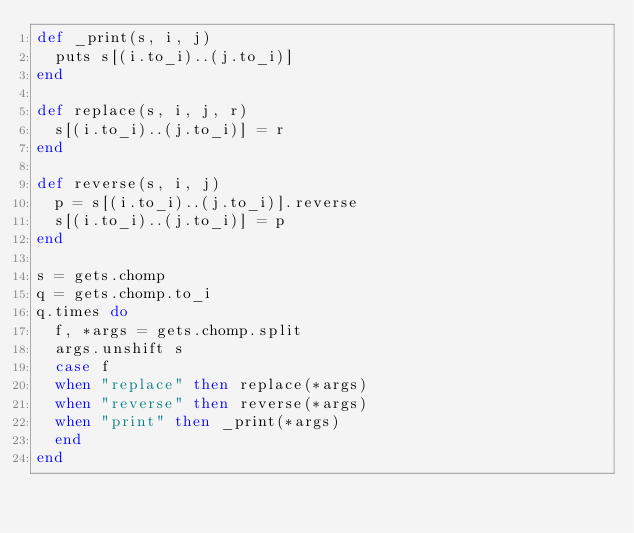<code> <loc_0><loc_0><loc_500><loc_500><_Ruby_>def _print(s, i, j)
  puts s[(i.to_i)..(j.to_i)]
end

def replace(s, i, j, r)
  s[(i.to_i)..(j.to_i)] = r
end

def reverse(s, i, j)
  p = s[(i.to_i)..(j.to_i)].reverse
  s[(i.to_i)..(j.to_i)] = p
end

s = gets.chomp
q = gets.chomp.to_i
q.times do
  f, *args = gets.chomp.split
  args.unshift s
  case f
  when "replace" then replace(*args)
  when "reverse" then reverse(*args)
  when "print" then _print(*args)
  end
end

</code> 